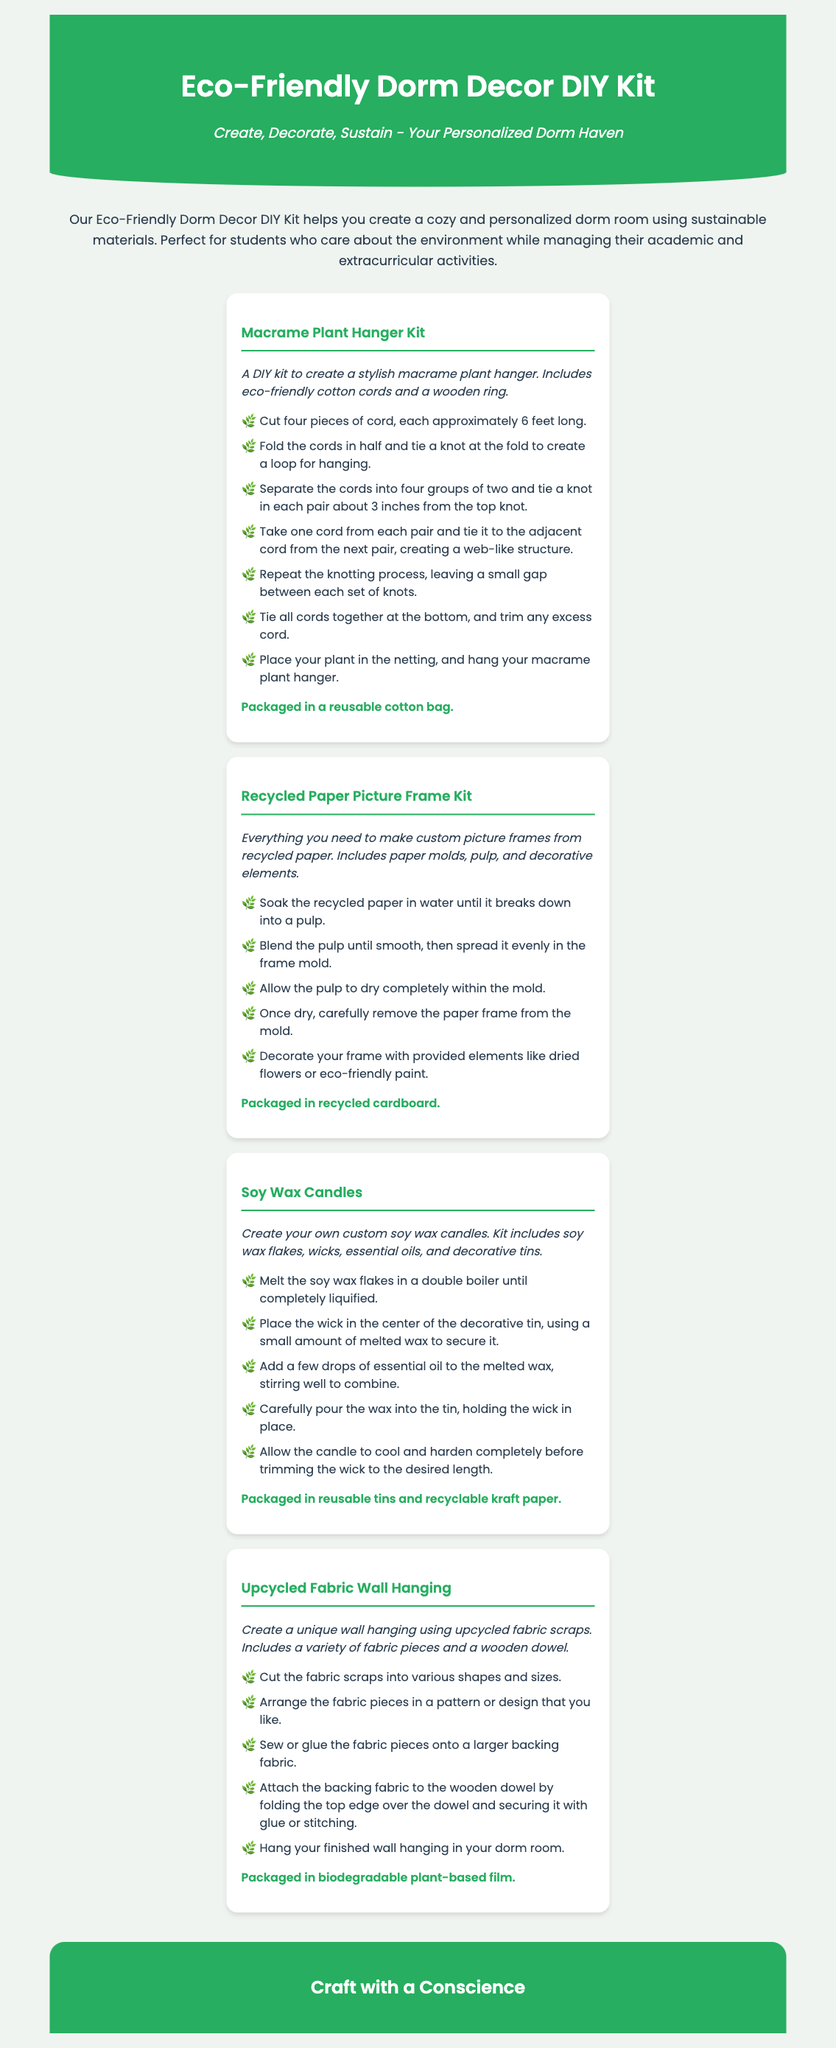What is the title of the product? The title of the product is prominently featured at the top of the document, labeled as "Eco-Friendly Dorm Decor DIY Kit."
Answer: Eco-Friendly Dorm Decor DIY Kit How many DIY kits are included in the document? The document lists four different DIY kits as part of the product offer.
Answer: Four What is one material included in the Macrame Plant Hanger Kit? The description of the Macrame Plant Hanger Kit mentions eco-friendly cotton cords as part of the materials included.
Answer: Cotton cords What is the packaging type for the Recycled Paper Picture Frame Kit? The document specifies that the Recycled Paper Picture Frame Kit is packaged in recycled cardboard.
Answer: Recycled cardboard What is a key feature of the DIY kits in relation to the environment? The document emphasizes that all DIY kits are made using sustainable materials, aligning with environmentally friendly practices.
Answer: Sustainable materials What step involves decorating the recycled paper frame? The instructions for the Recycled Paper Picture Frame Kit mention decorating with provided elements after removing the frame from the mold.
Answer: Decorate your frame What is one element that is included in the Soy Wax Candles kit? The Soy Wax Candles kit includes essential oils as one of the components necessary for making the candles.
Answer: Essential oils What is the final step in creating the Upcycled Fabric Wall Hanging? The instruction for the Upcycled Fabric Wall Hanging mentions hanging the finished product in your dorm room as the final step.
Answer: Hang your finished wall hanging What is the slogan at the end of the document? The document includes a slogan at the bottom, encapsulating the essence of the product and its eco-friendliness.
Answer: Craft with a Conscience 